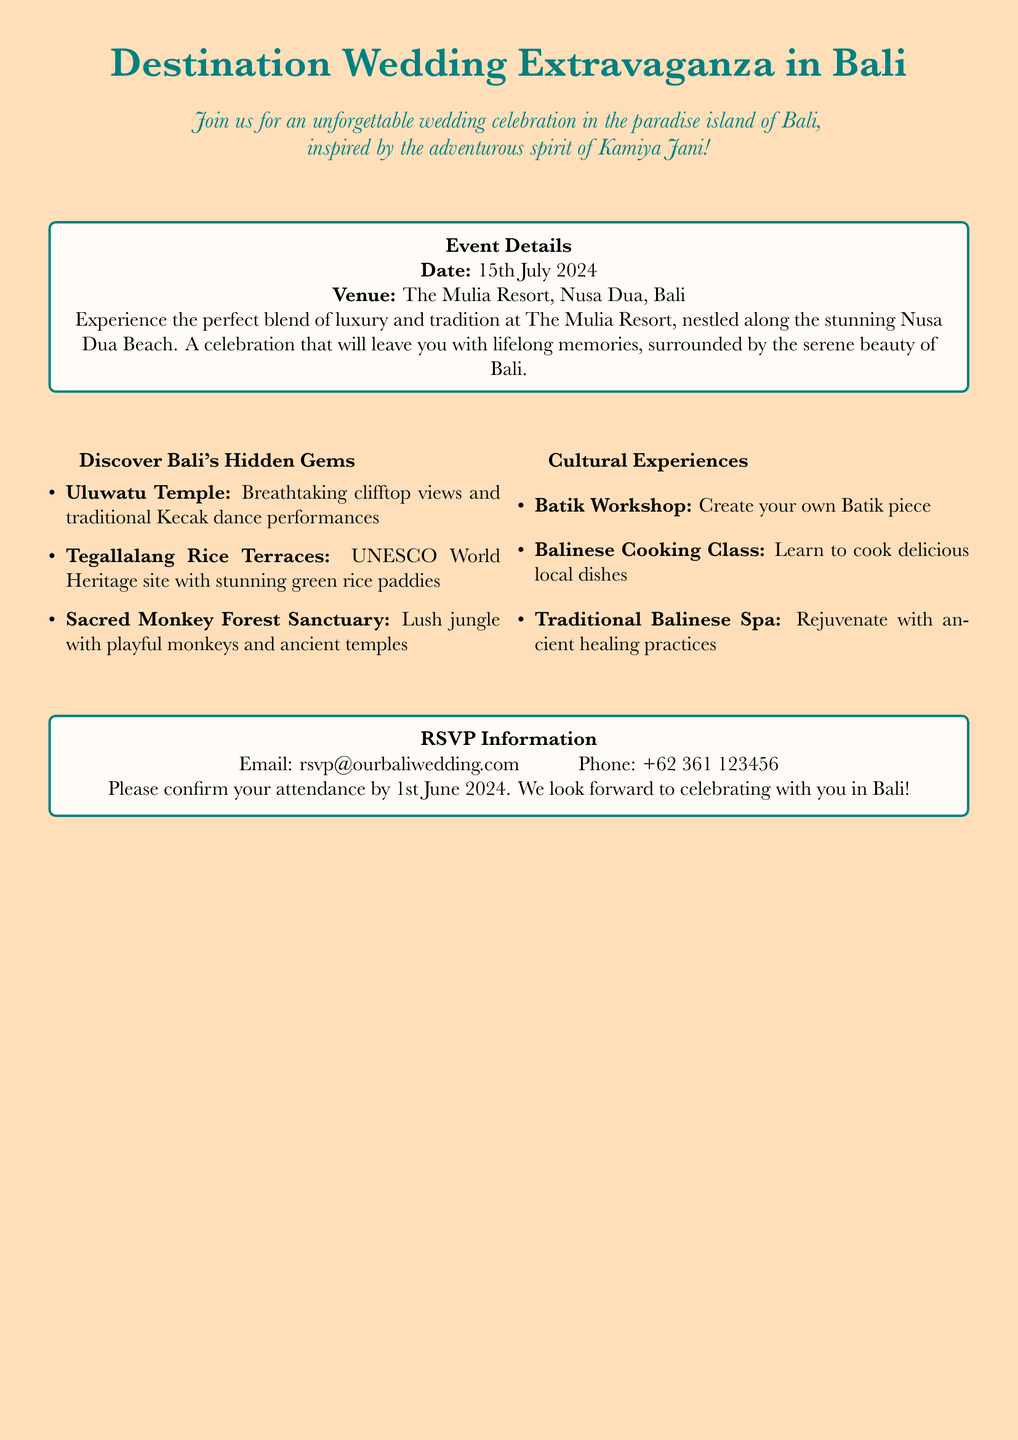what is the date of the wedding? The date of the wedding is explicitly mentioned in the event details section of the document.
Answer: 15th July 2024 where is the venue located? The venue is specifically named in the event details, providing its location in Bali.
Answer: The Mulia Resort, Nusa Dua, Bali what should attendees confirm by 1st June 2024? The RSVP section clarifies the information attendees need to confirm by a certain date.
Answer: Attendance what is one cultural experience mentioned? The cultural experiences section lists various activities; one example can be selected from this section.
Answer: Batik Workshop what is the contact email provided for RSVP? The RSVP section includes specific contact details for attendees to reach out.
Answer: rsvp@ourbaliwedding.com name one hidden gem to visit in Bali. The hidden gems section lists various locations; one can be chosen as an example from this list.
Answer: Uluwatu Temple how do the event details highlight the wedding experience? The venue description emphasizes the blend of luxury and tradition, capturing a unique aspect of the wedding experience in Bali.
Answer: Luxury and tradition what aspect of Bali is emphasized in the invitation theme? The invitation theme seeks to reflect the spirit of the renowned travel personality associated with discovering unique experiences.
Answer: Adventurous spirit of Kamiya Jani 